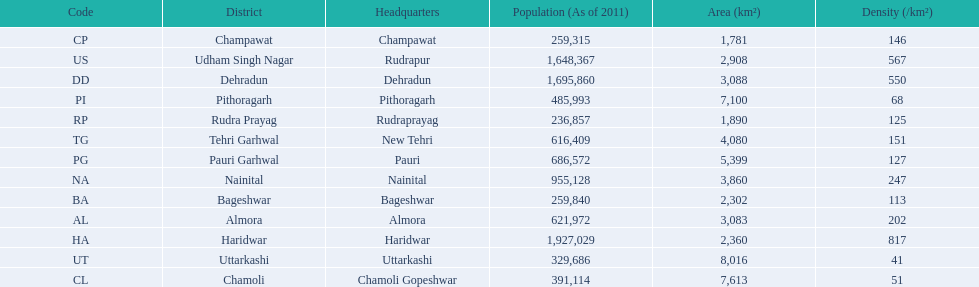What are the names of all the districts? Almora, Bageshwar, Chamoli, Champawat, Dehradun, Haridwar, Nainital, Pauri Garhwal, Pithoragarh, Rudra Prayag, Tehri Garhwal, Udham Singh Nagar, Uttarkashi. What range of densities do these districts encompass? 202, 113, 51, 146, 550, 817, 247, 127, 68, 125, 151, 567, 41. Which district has a density of 51? Chamoli. 